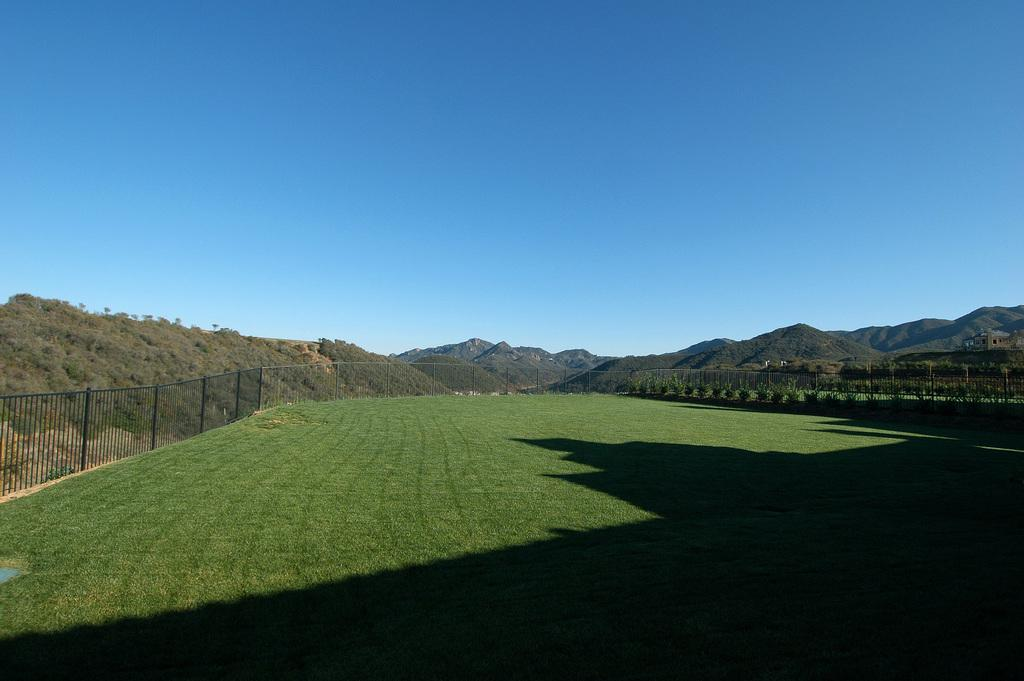What type of vegetation is at the bottom of the image? There is grass at the bottom of the image. What structure is in the center of the image? There is a fence in the center of the image. What can be seen in the distance in the image? Hills are visible in the background of the image. What else is visible in the background of the image? The sky is visible in the background of the image. Where is the chair located in the image? There is no chair present in the image. How many apples are on the grass in the image? There are no apples present in the image. 